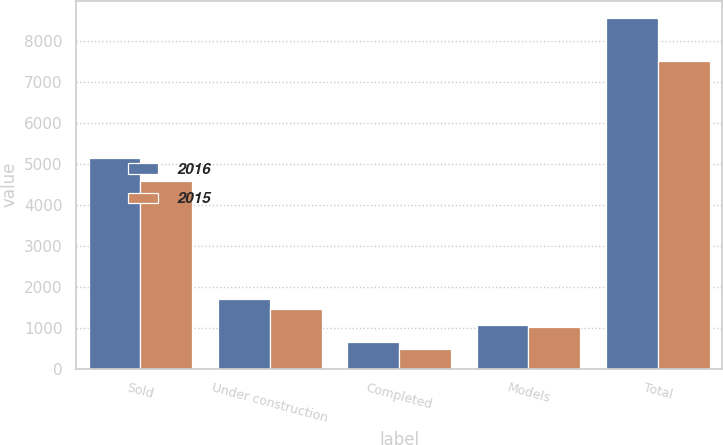Convert chart. <chart><loc_0><loc_0><loc_500><loc_500><stacked_bar_chart><ecel><fcel>Sold<fcel>Under construction<fcel>Completed<fcel>Models<fcel>Total<nl><fcel>2016<fcel>5138<fcel>1703<fcel>645<fcel>1072<fcel>8558<nl><fcel>2015<fcel>4573<fcel>1450<fcel>471<fcel>1024<fcel>7518<nl></chart> 